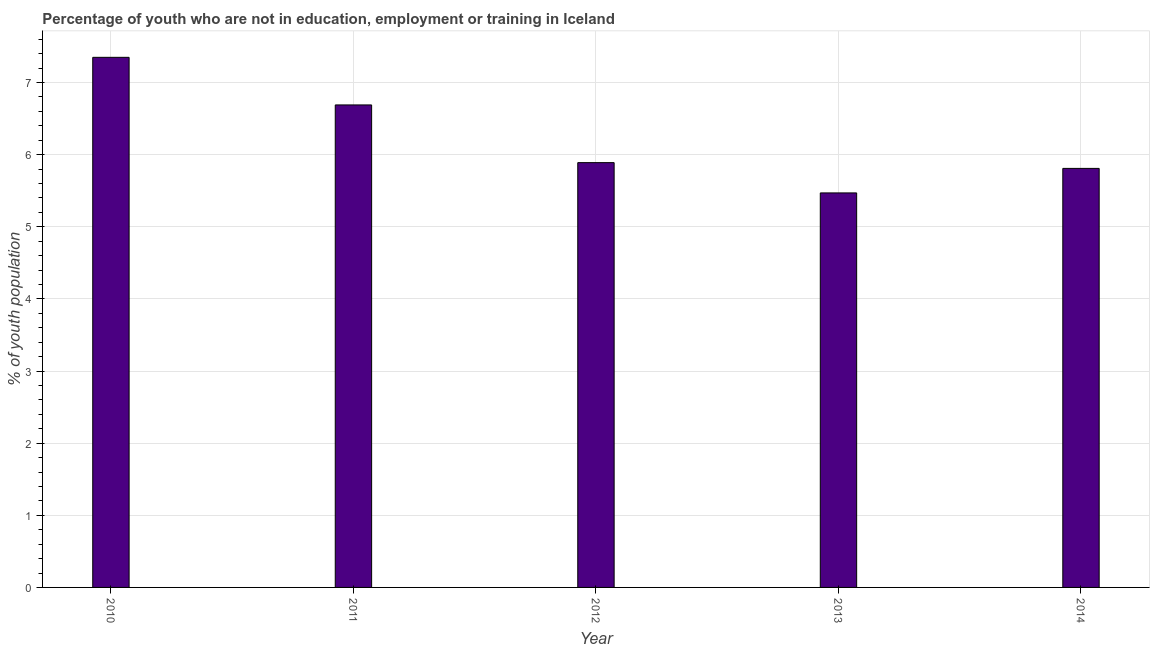Does the graph contain grids?
Your answer should be very brief. Yes. What is the title of the graph?
Your answer should be very brief. Percentage of youth who are not in education, employment or training in Iceland. What is the label or title of the X-axis?
Make the answer very short. Year. What is the label or title of the Y-axis?
Offer a terse response. % of youth population. What is the unemployed youth population in 2014?
Your answer should be very brief. 5.81. Across all years, what is the maximum unemployed youth population?
Your response must be concise. 7.35. Across all years, what is the minimum unemployed youth population?
Provide a short and direct response. 5.47. In which year was the unemployed youth population maximum?
Your response must be concise. 2010. What is the sum of the unemployed youth population?
Provide a succinct answer. 31.21. What is the average unemployed youth population per year?
Your answer should be compact. 6.24. What is the median unemployed youth population?
Offer a terse response. 5.89. Do a majority of the years between 2010 and 2012 (inclusive) have unemployed youth population greater than 6 %?
Provide a succinct answer. Yes. What is the ratio of the unemployed youth population in 2010 to that in 2011?
Offer a very short reply. 1.1. Is the unemployed youth population in 2010 less than that in 2013?
Offer a terse response. No. What is the difference between the highest and the second highest unemployed youth population?
Ensure brevity in your answer.  0.66. What is the difference between the highest and the lowest unemployed youth population?
Make the answer very short. 1.88. In how many years, is the unemployed youth population greater than the average unemployed youth population taken over all years?
Provide a short and direct response. 2. How many bars are there?
Offer a terse response. 5. How many years are there in the graph?
Your response must be concise. 5. Are the values on the major ticks of Y-axis written in scientific E-notation?
Offer a very short reply. No. What is the % of youth population in 2010?
Offer a very short reply. 7.35. What is the % of youth population in 2011?
Offer a terse response. 6.69. What is the % of youth population in 2012?
Make the answer very short. 5.89. What is the % of youth population in 2013?
Your answer should be very brief. 5.47. What is the % of youth population of 2014?
Offer a terse response. 5.81. What is the difference between the % of youth population in 2010 and 2011?
Ensure brevity in your answer.  0.66. What is the difference between the % of youth population in 2010 and 2012?
Provide a short and direct response. 1.46. What is the difference between the % of youth population in 2010 and 2013?
Provide a short and direct response. 1.88. What is the difference between the % of youth population in 2010 and 2014?
Your response must be concise. 1.54. What is the difference between the % of youth population in 2011 and 2013?
Ensure brevity in your answer.  1.22. What is the difference between the % of youth population in 2011 and 2014?
Make the answer very short. 0.88. What is the difference between the % of youth population in 2012 and 2013?
Make the answer very short. 0.42. What is the difference between the % of youth population in 2012 and 2014?
Provide a short and direct response. 0.08. What is the difference between the % of youth population in 2013 and 2014?
Keep it short and to the point. -0.34. What is the ratio of the % of youth population in 2010 to that in 2011?
Offer a terse response. 1.1. What is the ratio of the % of youth population in 2010 to that in 2012?
Provide a succinct answer. 1.25. What is the ratio of the % of youth population in 2010 to that in 2013?
Offer a terse response. 1.34. What is the ratio of the % of youth population in 2010 to that in 2014?
Provide a short and direct response. 1.26. What is the ratio of the % of youth population in 2011 to that in 2012?
Provide a succinct answer. 1.14. What is the ratio of the % of youth population in 2011 to that in 2013?
Keep it short and to the point. 1.22. What is the ratio of the % of youth population in 2011 to that in 2014?
Offer a terse response. 1.15. What is the ratio of the % of youth population in 2012 to that in 2013?
Keep it short and to the point. 1.08. What is the ratio of the % of youth population in 2013 to that in 2014?
Your answer should be very brief. 0.94. 